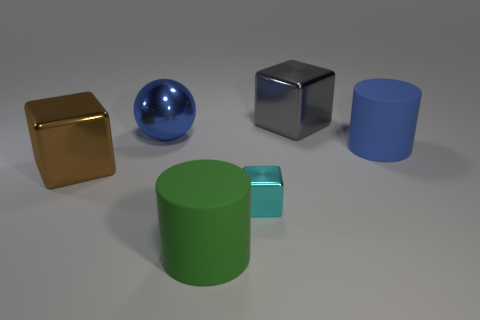What number of objects are big red blocks or rubber cylinders right of the big gray metallic thing?
Offer a very short reply. 1. There is a large metal object that is on the right side of the large matte cylinder in front of the large shiny cube that is on the left side of the big gray cube; what color is it?
Your answer should be very brief. Gray. What is the material of the blue object that is the same shape as the green thing?
Give a very brief answer. Rubber. What color is the big sphere?
Give a very brief answer. Blue. How many matte things are either tiny blue balls or green cylinders?
Offer a terse response. 1. There is a large block that is on the left side of the thing in front of the tiny cyan cube; is there a big thing that is in front of it?
Make the answer very short. Yes. There is a brown object that is the same material as the gray thing; what size is it?
Offer a terse response. Large. Are there any large brown shiny blocks on the right side of the gray metallic cube?
Your answer should be compact. No. Are there any large blue spheres that are behind the rubber cylinder right of the tiny metallic block?
Make the answer very short. Yes. Is the size of the cube that is left of the cyan block the same as the cyan cube that is in front of the blue rubber thing?
Your response must be concise. No. 